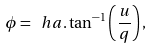Convert formula to latex. <formula><loc_0><loc_0><loc_500><loc_500>\phi = \ h a . \tan ^ { - 1 } \left ( \frac { u } { q } \right ) ,</formula> 